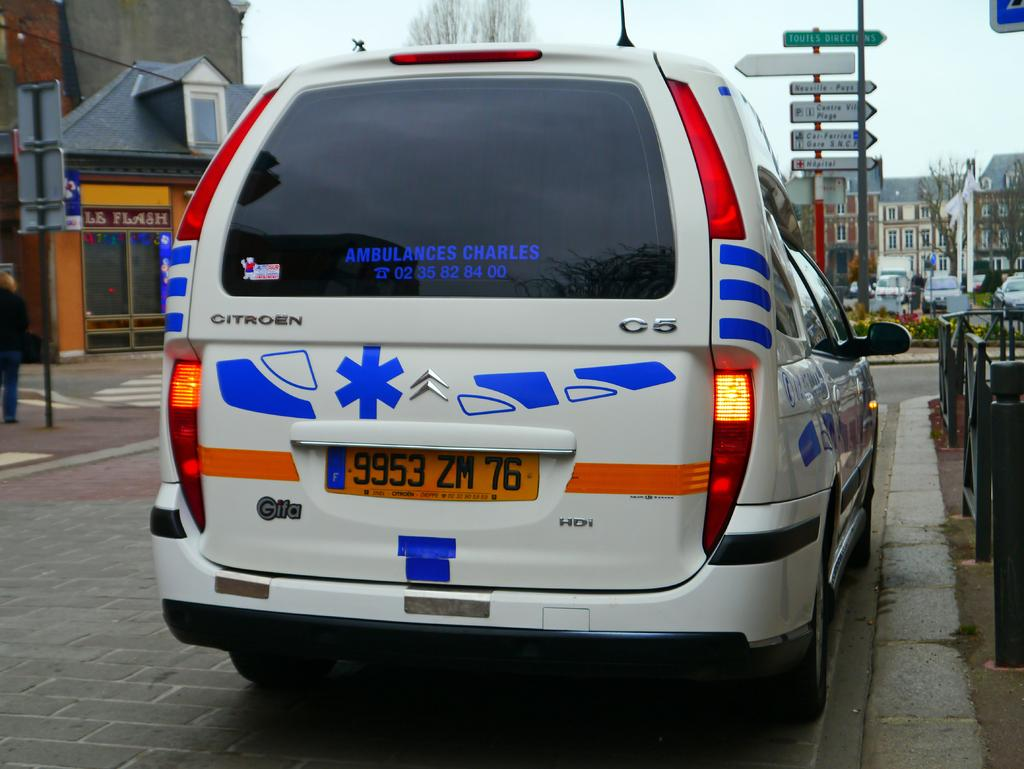What is the main subject of the image? There is a vehicle on a road in the image. What can be seen in the background of the image? There are buildings, sign boards, a tree, and the sky visible in the background of the image. How many buns can be seen on the vehicle in the image? There are no buns visible on the vehicle in the image. Can you tell me how many beads are hanging from the tree in the image? There are no beads hanging from the tree in the image; only the tree itself is visible. 